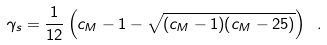<formula> <loc_0><loc_0><loc_500><loc_500>\gamma _ { s } = \frac { 1 } { 1 2 } \left ( c _ { M } - 1 - \sqrt { ( c _ { M } - 1 ) ( c _ { M } - 2 5 ) } \right ) \ .</formula> 